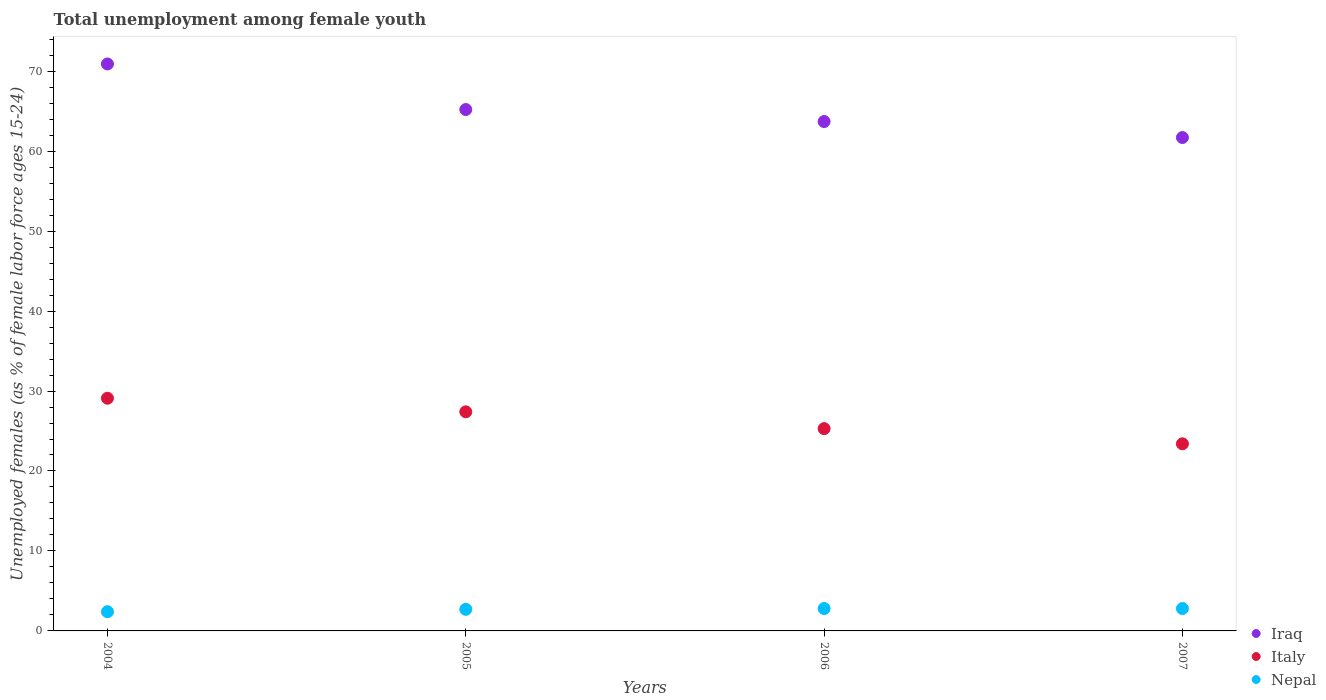How many different coloured dotlines are there?
Your response must be concise. 3. What is the percentage of unemployed females in in Nepal in 2005?
Make the answer very short. 2.7. Across all years, what is the maximum percentage of unemployed females in in Iraq?
Offer a very short reply. 70.9. Across all years, what is the minimum percentage of unemployed females in in Italy?
Provide a short and direct response. 23.4. In which year was the percentage of unemployed females in in Italy maximum?
Offer a very short reply. 2004. What is the total percentage of unemployed females in in Italy in the graph?
Give a very brief answer. 105.2. What is the difference between the percentage of unemployed females in in Nepal in 2005 and that in 2007?
Offer a very short reply. -0.1. What is the difference between the percentage of unemployed females in in Iraq in 2004 and the percentage of unemployed females in in Nepal in 2007?
Provide a succinct answer. 68.1. What is the average percentage of unemployed females in in Nepal per year?
Offer a terse response. 2.68. In the year 2004, what is the difference between the percentage of unemployed females in in Italy and percentage of unemployed females in in Iraq?
Offer a terse response. -41.8. In how many years, is the percentage of unemployed females in in Nepal greater than 46 %?
Your answer should be compact. 0. What is the ratio of the percentage of unemployed females in in Nepal in 2006 to that in 2007?
Give a very brief answer. 1. Is the difference between the percentage of unemployed females in in Italy in 2004 and 2006 greater than the difference between the percentage of unemployed females in in Iraq in 2004 and 2006?
Offer a terse response. No. What is the difference between the highest and the second highest percentage of unemployed females in in Iraq?
Offer a terse response. 5.7. What is the difference between the highest and the lowest percentage of unemployed females in in Italy?
Ensure brevity in your answer.  5.7. Is it the case that in every year, the sum of the percentage of unemployed females in in Nepal and percentage of unemployed females in in Italy  is greater than the percentage of unemployed females in in Iraq?
Your answer should be compact. No. Is the percentage of unemployed females in in Iraq strictly less than the percentage of unemployed females in in Italy over the years?
Keep it short and to the point. No. How many years are there in the graph?
Provide a succinct answer. 4. What is the difference between two consecutive major ticks on the Y-axis?
Your answer should be very brief. 10. Where does the legend appear in the graph?
Provide a succinct answer. Bottom right. How many legend labels are there?
Your response must be concise. 3. What is the title of the graph?
Provide a succinct answer. Total unemployment among female youth. What is the label or title of the Y-axis?
Provide a succinct answer. Unemployed females (as % of female labor force ages 15-24). What is the Unemployed females (as % of female labor force ages 15-24) in Iraq in 2004?
Provide a succinct answer. 70.9. What is the Unemployed females (as % of female labor force ages 15-24) of Italy in 2004?
Your answer should be compact. 29.1. What is the Unemployed females (as % of female labor force ages 15-24) in Nepal in 2004?
Offer a terse response. 2.4. What is the Unemployed females (as % of female labor force ages 15-24) in Iraq in 2005?
Your response must be concise. 65.2. What is the Unemployed females (as % of female labor force ages 15-24) in Italy in 2005?
Your response must be concise. 27.4. What is the Unemployed females (as % of female labor force ages 15-24) of Nepal in 2005?
Provide a short and direct response. 2.7. What is the Unemployed females (as % of female labor force ages 15-24) of Iraq in 2006?
Ensure brevity in your answer.  63.7. What is the Unemployed females (as % of female labor force ages 15-24) in Italy in 2006?
Keep it short and to the point. 25.3. What is the Unemployed females (as % of female labor force ages 15-24) of Nepal in 2006?
Your response must be concise. 2.8. What is the Unemployed females (as % of female labor force ages 15-24) of Iraq in 2007?
Ensure brevity in your answer.  61.7. What is the Unemployed females (as % of female labor force ages 15-24) of Italy in 2007?
Your answer should be compact. 23.4. What is the Unemployed females (as % of female labor force ages 15-24) in Nepal in 2007?
Make the answer very short. 2.8. Across all years, what is the maximum Unemployed females (as % of female labor force ages 15-24) in Iraq?
Offer a terse response. 70.9. Across all years, what is the maximum Unemployed females (as % of female labor force ages 15-24) of Italy?
Your answer should be very brief. 29.1. Across all years, what is the maximum Unemployed females (as % of female labor force ages 15-24) of Nepal?
Offer a terse response. 2.8. Across all years, what is the minimum Unemployed females (as % of female labor force ages 15-24) of Iraq?
Your answer should be compact. 61.7. Across all years, what is the minimum Unemployed females (as % of female labor force ages 15-24) of Italy?
Your response must be concise. 23.4. Across all years, what is the minimum Unemployed females (as % of female labor force ages 15-24) of Nepal?
Ensure brevity in your answer.  2.4. What is the total Unemployed females (as % of female labor force ages 15-24) of Iraq in the graph?
Keep it short and to the point. 261.5. What is the total Unemployed females (as % of female labor force ages 15-24) of Italy in the graph?
Provide a succinct answer. 105.2. What is the total Unemployed females (as % of female labor force ages 15-24) in Nepal in the graph?
Keep it short and to the point. 10.7. What is the difference between the Unemployed females (as % of female labor force ages 15-24) of Iraq in 2004 and that in 2005?
Offer a very short reply. 5.7. What is the difference between the Unemployed females (as % of female labor force ages 15-24) of Nepal in 2004 and that in 2005?
Provide a short and direct response. -0.3. What is the difference between the Unemployed females (as % of female labor force ages 15-24) of Nepal in 2004 and that in 2006?
Offer a terse response. -0.4. What is the difference between the Unemployed females (as % of female labor force ages 15-24) in Italy in 2004 and that in 2007?
Keep it short and to the point. 5.7. What is the difference between the Unemployed females (as % of female labor force ages 15-24) of Iraq in 2005 and that in 2006?
Keep it short and to the point. 1.5. What is the difference between the Unemployed females (as % of female labor force ages 15-24) of Italy in 2005 and that in 2006?
Your answer should be compact. 2.1. What is the difference between the Unemployed females (as % of female labor force ages 15-24) of Nepal in 2005 and that in 2007?
Your answer should be compact. -0.1. What is the difference between the Unemployed females (as % of female labor force ages 15-24) in Iraq in 2006 and that in 2007?
Ensure brevity in your answer.  2. What is the difference between the Unemployed females (as % of female labor force ages 15-24) in Italy in 2006 and that in 2007?
Your answer should be very brief. 1.9. What is the difference between the Unemployed females (as % of female labor force ages 15-24) in Nepal in 2006 and that in 2007?
Your response must be concise. 0. What is the difference between the Unemployed females (as % of female labor force ages 15-24) of Iraq in 2004 and the Unemployed females (as % of female labor force ages 15-24) of Italy in 2005?
Your response must be concise. 43.5. What is the difference between the Unemployed females (as % of female labor force ages 15-24) of Iraq in 2004 and the Unemployed females (as % of female labor force ages 15-24) of Nepal in 2005?
Provide a short and direct response. 68.2. What is the difference between the Unemployed females (as % of female labor force ages 15-24) in Italy in 2004 and the Unemployed females (as % of female labor force ages 15-24) in Nepal in 2005?
Your response must be concise. 26.4. What is the difference between the Unemployed females (as % of female labor force ages 15-24) of Iraq in 2004 and the Unemployed females (as % of female labor force ages 15-24) of Italy in 2006?
Your answer should be compact. 45.6. What is the difference between the Unemployed females (as % of female labor force ages 15-24) in Iraq in 2004 and the Unemployed females (as % of female labor force ages 15-24) in Nepal in 2006?
Offer a terse response. 68.1. What is the difference between the Unemployed females (as % of female labor force ages 15-24) of Italy in 2004 and the Unemployed females (as % of female labor force ages 15-24) of Nepal in 2006?
Your answer should be compact. 26.3. What is the difference between the Unemployed females (as % of female labor force ages 15-24) of Iraq in 2004 and the Unemployed females (as % of female labor force ages 15-24) of Italy in 2007?
Ensure brevity in your answer.  47.5. What is the difference between the Unemployed females (as % of female labor force ages 15-24) of Iraq in 2004 and the Unemployed females (as % of female labor force ages 15-24) of Nepal in 2007?
Give a very brief answer. 68.1. What is the difference between the Unemployed females (as % of female labor force ages 15-24) in Italy in 2004 and the Unemployed females (as % of female labor force ages 15-24) in Nepal in 2007?
Your answer should be very brief. 26.3. What is the difference between the Unemployed females (as % of female labor force ages 15-24) of Iraq in 2005 and the Unemployed females (as % of female labor force ages 15-24) of Italy in 2006?
Your answer should be very brief. 39.9. What is the difference between the Unemployed females (as % of female labor force ages 15-24) in Iraq in 2005 and the Unemployed females (as % of female labor force ages 15-24) in Nepal in 2006?
Give a very brief answer. 62.4. What is the difference between the Unemployed females (as % of female labor force ages 15-24) of Italy in 2005 and the Unemployed females (as % of female labor force ages 15-24) of Nepal in 2006?
Offer a terse response. 24.6. What is the difference between the Unemployed females (as % of female labor force ages 15-24) of Iraq in 2005 and the Unemployed females (as % of female labor force ages 15-24) of Italy in 2007?
Provide a succinct answer. 41.8. What is the difference between the Unemployed females (as % of female labor force ages 15-24) of Iraq in 2005 and the Unemployed females (as % of female labor force ages 15-24) of Nepal in 2007?
Your response must be concise. 62.4. What is the difference between the Unemployed females (as % of female labor force ages 15-24) of Italy in 2005 and the Unemployed females (as % of female labor force ages 15-24) of Nepal in 2007?
Your answer should be compact. 24.6. What is the difference between the Unemployed females (as % of female labor force ages 15-24) of Iraq in 2006 and the Unemployed females (as % of female labor force ages 15-24) of Italy in 2007?
Offer a very short reply. 40.3. What is the difference between the Unemployed females (as % of female labor force ages 15-24) of Iraq in 2006 and the Unemployed females (as % of female labor force ages 15-24) of Nepal in 2007?
Your response must be concise. 60.9. What is the difference between the Unemployed females (as % of female labor force ages 15-24) in Italy in 2006 and the Unemployed females (as % of female labor force ages 15-24) in Nepal in 2007?
Offer a terse response. 22.5. What is the average Unemployed females (as % of female labor force ages 15-24) of Iraq per year?
Offer a terse response. 65.38. What is the average Unemployed females (as % of female labor force ages 15-24) in Italy per year?
Offer a terse response. 26.3. What is the average Unemployed females (as % of female labor force ages 15-24) of Nepal per year?
Give a very brief answer. 2.67. In the year 2004, what is the difference between the Unemployed females (as % of female labor force ages 15-24) of Iraq and Unemployed females (as % of female labor force ages 15-24) of Italy?
Keep it short and to the point. 41.8. In the year 2004, what is the difference between the Unemployed females (as % of female labor force ages 15-24) of Iraq and Unemployed females (as % of female labor force ages 15-24) of Nepal?
Make the answer very short. 68.5. In the year 2004, what is the difference between the Unemployed females (as % of female labor force ages 15-24) in Italy and Unemployed females (as % of female labor force ages 15-24) in Nepal?
Keep it short and to the point. 26.7. In the year 2005, what is the difference between the Unemployed females (as % of female labor force ages 15-24) of Iraq and Unemployed females (as % of female labor force ages 15-24) of Italy?
Make the answer very short. 37.8. In the year 2005, what is the difference between the Unemployed females (as % of female labor force ages 15-24) in Iraq and Unemployed females (as % of female labor force ages 15-24) in Nepal?
Your answer should be compact. 62.5. In the year 2005, what is the difference between the Unemployed females (as % of female labor force ages 15-24) in Italy and Unemployed females (as % of female labor force ages 15-24) in Nepal?
Provide a short and direct response. 24.7. In the year 2006, what is the difference between the Unemployed females (as % of female labor force ages 15-24) of Iraq and Unemployed females (as % of female labor force ages 15-24) of Italy?
Make the answer very short. 38.4. In the year 2006, what is the difference between the Unemployed females (as % of female labor force ages 15-24) of Iraq and Unemployed females (as % of female labor force ages 15-24) of Nepal?
Offer a very short reply. 60.9. In the year 2007, what is the difference between the Unemployed females (as % of female labor force ages 15-24) of Iraq and Unemployed females (as % of female labor force ages 15-24) of Italy?
Make the answer very short. 38.3. In the year 2007, what is the difference between the Unemployed females (as % of female labor force ages 15-24) of Iraq and Unemployed females (as % of female labor force ages 15-24) of Nepal?
Give a very brief answer. 58.9. In the year 2007, what is the difference between the Unemployed females (as % of female labor force ages 15-24) of Italy and Unemployed females (as % of female labor force ages 15-24) of Nepal?
Make the answer very short. 20.6. What is the ratio of the Unemployed females (as % of female labor force ages 15-24) of Iraq in 2004 to that in 2005?
Keep it short and to the point. 1.09. What is the ratio of the Unemployed females (as % of female labor force ages 15-24) in Italy in 2004 to that in 2005?
Provide a succinct answer. 1.06. What is the ratio of the Unemployed females (as % of female labor force ages 15-24) in Iraq in 2004 to that in 2006?
Your answer should be compact. 1.11. What is the ratio of the Unemployed females (as % of female labor force ages 15-24) of Italy in 2004 to that in 2006?
Provide a short and direct response. 1.15. What is the ratio of the Unemployed females (as % of female labor force ages 15-24) of Iraq in 2004 to that in 2007?
Ensure brevity in your answer.  1.15. What is the ratio of the Unemployed females (as % of female labor force ages 15-24) in Italy in 2004 to that in 2007?
Give a very brief answer. 1.24. What is the ratio of the Unemployed females (as % of female labor force ages 15-24) in Iraq in 2005 to that in 2006?
Offer a very short reply. 1.02. What is the ratio of the Unemployed females (as % of female labor force ages 15-24) in Italy in 2005 to that in 2006?
Make the answer very short. 1.08. What is the ratio of the Unemployed females (as % of female labor force ages 15-24) of Iraq in 2005 to that in 2007?
Ensure brevity in your answer.  1.06. What is the ratio of the Unemployed females (as % of female labor force ages 15-24) of Italy in 2005 to that in 2007?
Your response must be concise. 1.17. What is the ratio of the Unemployed females (as % of female labor force ages 15-24) of Nepal in 2005 to that in 2007?
Offer a very short reply. 0.96. What is the ratio of the Unemployed females (as % of female labor force ages 15-24) of Iraq in 2006 to that in 2007?
Ensure brevity in your answer.  1.03. What is the ratio of the Unemployed females (as % of female labor force ages 15-24) of Italy in 2006 to that in 2007?
Keep it short and to the point. 1.08. What is the difference between the highest and the second highest Unemployed females (as % of female labor force ages 15-24) in Iraq?
Give a very brief answer. 5.7. What is the difference between the highest and the second highest Unemployed females (as % of female labor force ages 15-24) of Nepal?
Provide a succinct answer. 0. What is the difference between the highest and the lowest Unemployed females (as % of female labor force ages 15-24) of Iraq?
Provide a succinct answer. 9.2. What is the difference between the highest and the lowest Unemployed females (as % of female labor force ages 15-24) in Italy?
Your answer should be very brief. 5.7. What is the difference between the highest and the lowest Unemployed females (as % of female labor force ages 15-24) of Nepal?
Provide a short and direct response. 0.4. 